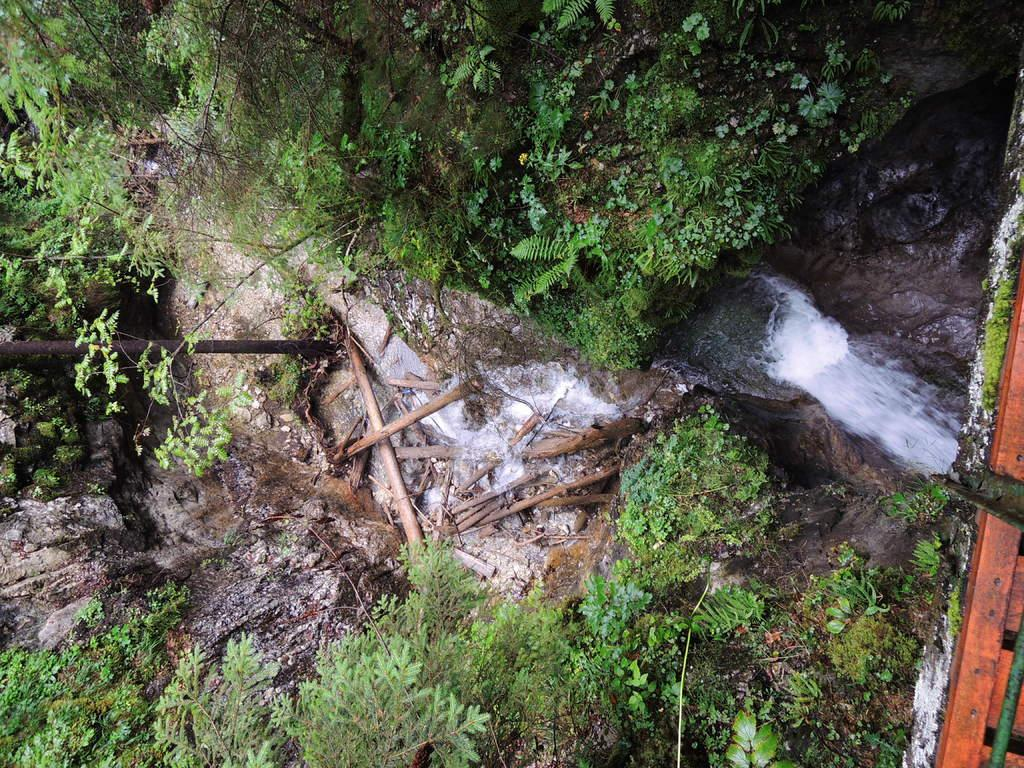What is the main feature in the middle of the image? There is water flowing in the middle of the image. What can be seen on either side of the water? There are rocks along with plants to the left and right of the water. What structure is visible to the right of the image? There appears to be a bridge to the right of the image. What type of religion is being practiced on the bridge in the image? There is no indication of any religious practice or gathering on the bridge in the image. 